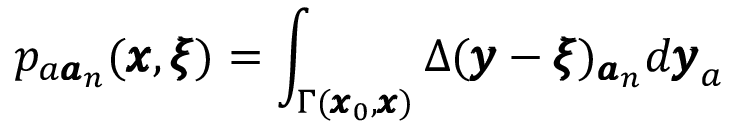Convert formula to latex. <formula><loc_0><loc_0><loc_500><loc_500>p _ { a { \pm b a } _ { n } } ( { \pm b x } , { \pm b \xi } ) = \int _ { \Gamma ( { \pm b x } _ { 0 } , { \pm b x } ) } \Delta ( { \pm b y } - { \pm b \xi } ) _ { { \pm b a } _ { n } } d { \pm b y } _ { a }</formula> 